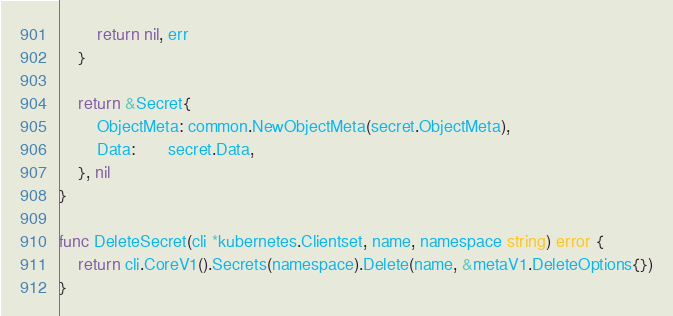<code> <loc_0><loc_0><loc_500><loc_500><_Go_>		return nil, err
	}

	return &Secret{
		ObjectMeta: common.NewObjectMeta(secret.ObjectMeta),
		Data:       secret.Data,
	}, nil
}

func DeleteSecret(cli *kubernetes.Clientset, name, namespace string) error {
	return cli.CoreV1().Secrets(namespace).Delete(name, &metaV1.DeleteOptions{})
}
</code> 